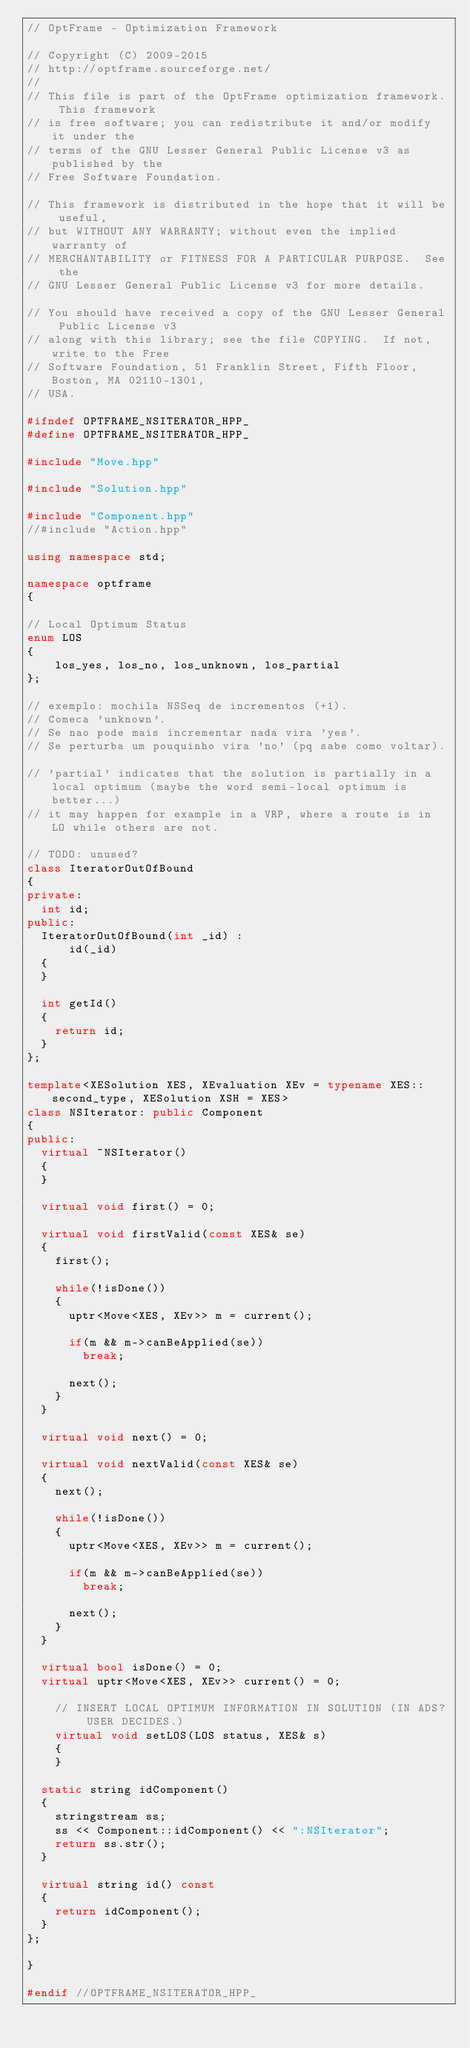<code> <loc_0><loc_0><loc_500><loc_500><_C++_>// OptFrame - Optimization Framework

// Copyright (C) 2009-2015
// http://optframe.sourceforge.net/
//
// This file is part of the OptFrame optimization framework. This framework
// is free software; you can redistribute it and/or modify it under the
// terms of the GNU Lesser General Public License v3 as published by the
// Free Software Foundation.

// This framework is distributed in the hope that it will be useful,
// but WITHOUT ANY WARRANTY; without even the implied warranty of
// MERCHANTABILITY or FITNESS FOR A PARTICULAR PURPOSE.  See the
// GNU Lesser General Public License v3 for more details.

// You should have received a copy of the GNU Lesser General Public License v3
// along with this library; see the file COPYING.  If not, write to the Free
// Software Foundation, 51 Franklin Street, Fifth Floor, Boston, MA 02110-1301,
// USA.

#ifndef OPTFRAME_NSITERATOR_HPP_
#define OPTFRAME_NSITERATOR_HPP_

#include "Move.hpp"

#include "Solution.hpp"

#include "Component.hpp"
//#include "Action.hpp"

using namespace std;

namespace optframe
{

// Local Optimum Status
enum LOS
{
    los_yes, los_no, los_unknown, los_partial
};

// exemplo: mochila NSSeq de incrementos (+1).
// Comeca 'unknown'.
// Se nao pode mais incrementar nada vira 'yes'.
// Se perturba um pouquinho vira 'no' (pq sabe como voltar).

// 'partial' indicates that the solution is partially in a local optimum (maybe the word semi-local optimum is better...)
// it may happen for example in a VRP, where a route is in LO while others are not.

// TODO: unused?
class IteratorOutOfBound
{
private:
	int id;
public:
	IteratorOutOfBound(int _id) :
			id(_id)
	{
	}

	int getId()
	{
		return id;
	}
};

template<XESolution XES, XEvaluation XEv = typename XES::second_type, XESolution XSH = XES>
class NSIterator: public Component
{
public:
	virtual ~NSIterator()
	{
	}

	virtual void first() = 0;

	virtual void firstValid(const XES& se)
	{
		first();

		while(!isDone())
		{
			uptr<Move<XES, XEv>> m = current();

			if(m && m->canBeApplied(se))
				break;

			next();
		}
	}

	virtual void next() = 0;

	virtual void nextValid(const XES& se)
	{
		next();

		while(!isDone())
		{
			uptr<Move<XES, XEv>> m = current();

			if(m && m->canBeApplied(se))
				break;

			next();
		}
	}

	virtual bool isDone() = 0;
	virtual uptr<Move<XES, XEv>> current() = 0;

    // INSERT LOCAL OPTIMUM INFORMATION IN SOLUTION (IN ADS? USER DECIDES.)
    virtual void setLOS(LOS status, XES& s)
    {
    }

	static string idComponent()
	{
		stringstream ss;
		ss << Component::idComponent() << ":NSIterator";
		return ss.str();
	}

	virtual string id() const
	{
		return idComponent();
	}
};

}

#endif //OPTFRAME_NSITERATOR_HPP_
</code> 